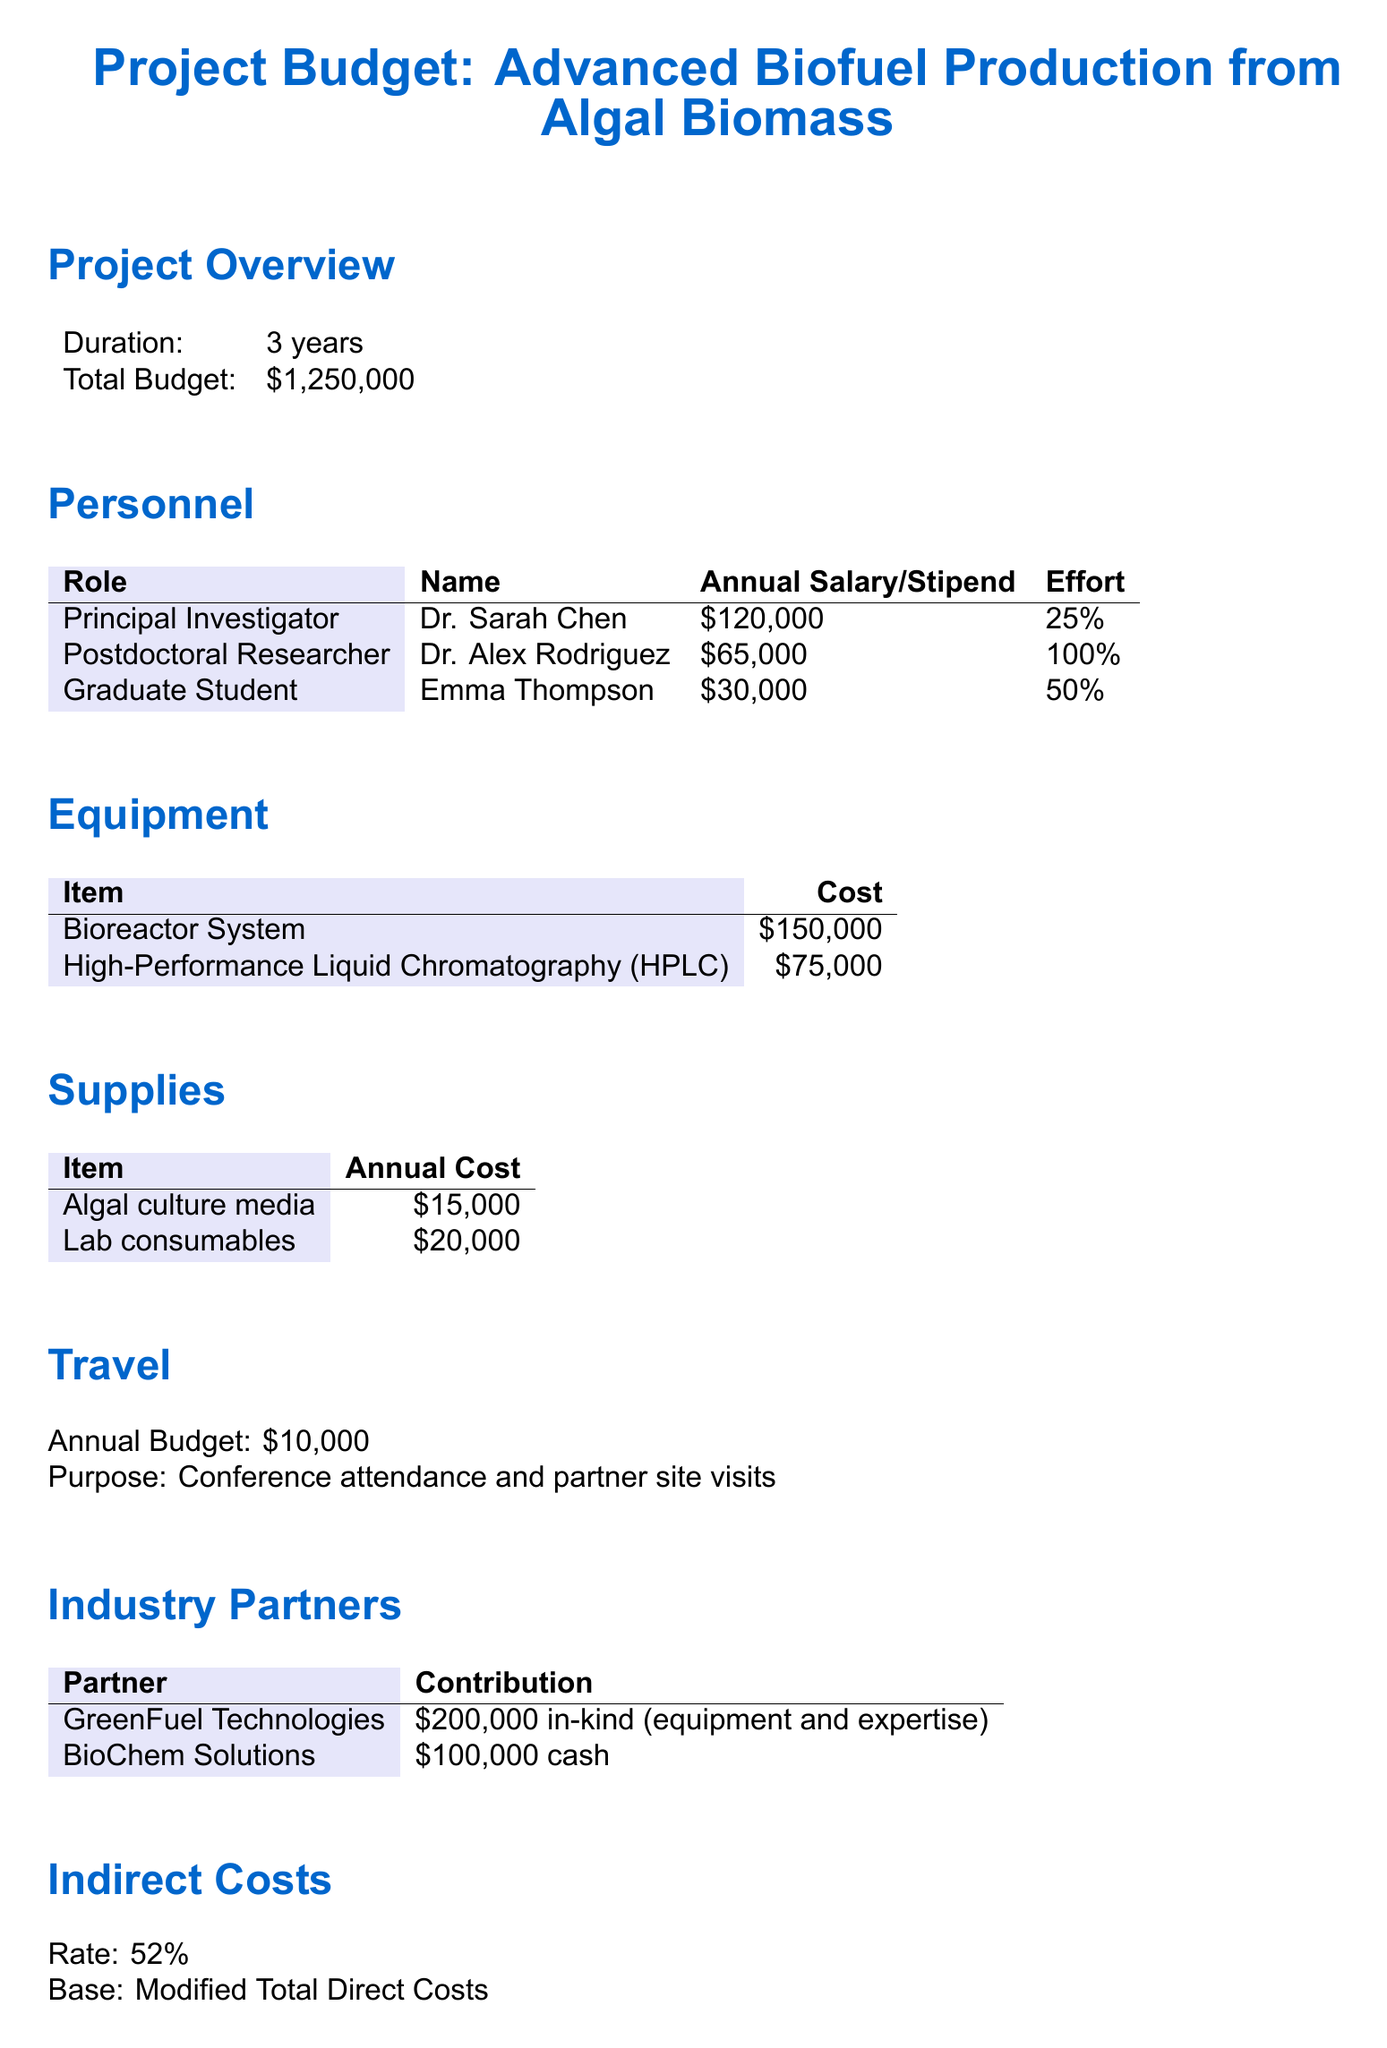What is the total budget for the project? The total budget is stated clearly in the document under the project overview section.
Answer: $1,250,000 Who is the Principal Investigator? The name of the Principal Investigator is given in the personnel section of the document.
Answer: Dr. Sarah Chen What is the annual salary of the Postdoctoral Researcher? The annual salary for the Postdoctoral Researcher is specified in the personnel section.
Answer: $65,000 How much is allocated annually for travel? The annual budget for travel is mentioned in the travel section of the document.
Answer: $10,000 What contribution does GreenFuel Technologies provide? The contribution from GreenFuel Technologies is detailed in the industry partners section.
Answer: $200,000 in-kind (equipment and expertise) What percentage is the indirect cost rate? The indirect cost rate is explicitly mentioned in the indirect costs section.
Answer: 52% How much is the annual cost for lab consumables? The annual cost for lab consumables is found in the supplies section.
Answer: $20,000 What is the duration of the project? The duration is stated in the project overview section.
Answer: 3 years What is the total cash contribution from BioChem Solutions? The cash contribution from BioChem Solutions is listed in the industry partners section.
Answer: $100,000 